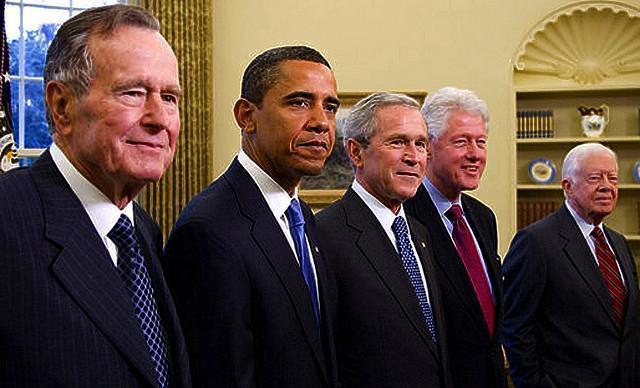How many men are wearing blue ties?
Give a very brief answer. 3. How many people are in the picture?
Give a very brief answer. 5. How many ties are in the picture?
Give a very brief answer. 2. How many zebras have stripes?
Give a very brief answer. 0. 